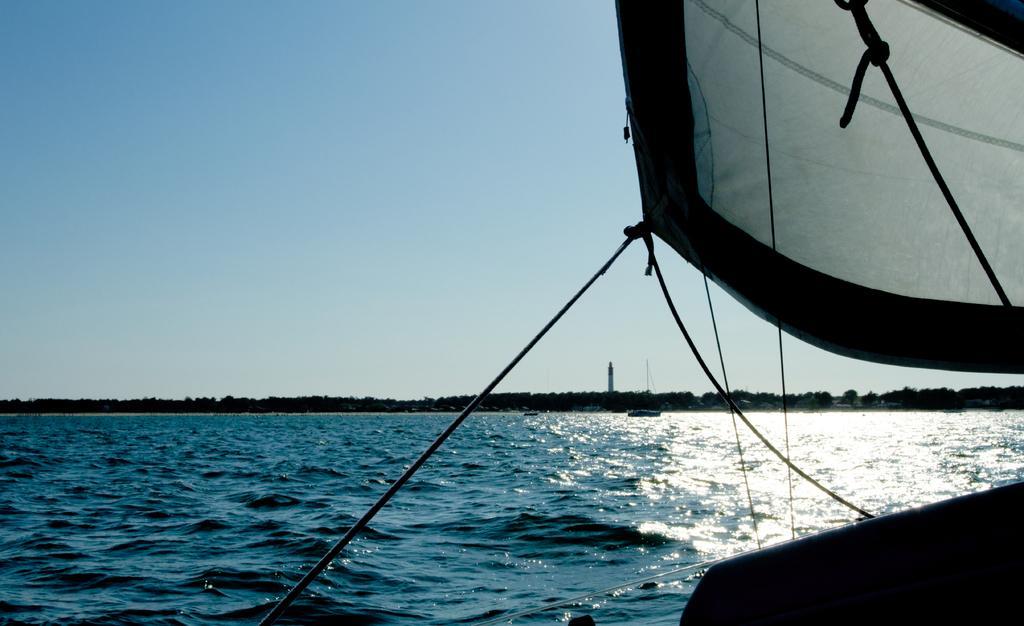Please provide a concise description of this image. In this picture we can see a boat on the water. In the background we can see towers, trees and beach. On the top there is a sky. Here we can see another boat. 